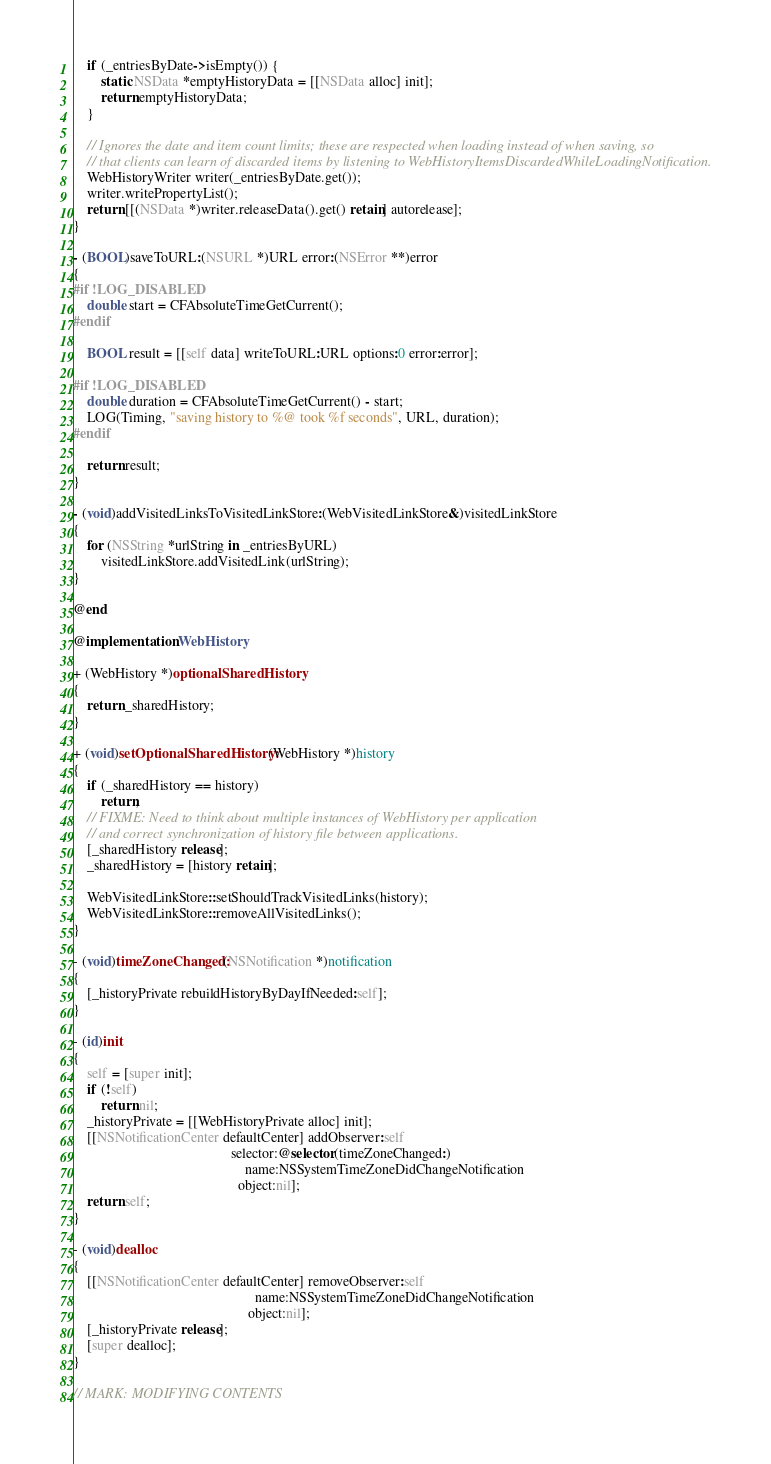Convert code to text. <code><loc_0><loc_0><loc_500><loc_500><_ObjectiveC_>    if (_entriesByDate->isEmpty()) {
        static NSData *emptyHistoryData = [[NSData alloc] init];
        return emptyHistoryData;
    }

    // Ignores the date and item count limits; these are respected when loading instead of when saving, so
    // that clients can learn of discarded items by listening to WebHistoryItemsDiscardedWhileLoadingNotification.
    WebHistoryWriter writer(_entriesByDate.get());
    writer.writePropertyList();
    return [[(NSData *)writer.releaseData().get() retain] autorelease];
}

- (BOOL)saveToURL:(NSURL *)URL error:(NSError **)error
{
#if !LOG_DISABLED
    double start = CFAbsoluteTimeGetCurrent();
#endif

    BOOL result = [[self data] writeToURL:URL options:0 error:error];

#if !LOG_DISABLED
    double duration = CFAbsoluteTimeGetCurrent() - start;
    LOG(Timing, "saving history to %@ took %f seconds", URL, duration);
#endif

    return result;
}

- (void)addVisitedLinksToVisitedLinkStore:(WebVisitedLinkStore&)visitedLinkStore
{
    for (NSString *urlString in _entriesByURL)
        visitedLinkStore.addVisitedLink(urlString);
}

@end

@implementation WebHistory

+ (WebHistory *)optionalSharedHistory
{
    return _sharedHistory;
}

+ (void)setOptionalSharedHistory:(WebHistory *)history
{
    if (_sharedHistory == history)
        return;
    // FIXME: Need to think about multiple instances of WebHistory per application
    // and correct synchronization of history file between applications.
    [_sharedHistory release];
    _sharedHistory = [history retain];

    WebVisitedLinkStore::setShouldTrackVisitedLinks(history);
    WebVisitedLinkStore::removeAllVisitedLinks();
}

- (void)timeZoneChanged:(NSNotification *)notification
{
    [_historyPrivate rebuildHistoryByDayIfNeeded:self];
}

- (id)init
{
    self = [super init];
    if (!self)
        return nil;
    _historyPrivate = [[WebHistoryPrivate alloc] init];
    [[NSNotificationCenter defaultCenter] addObserver:self
                                             selector:@selector(timeZoneChanged:)
                                                 name:NSSystemTimeZoneDidChangeNotification
                                               object:nil];
    return self;
}

- (void)dealloc
{
    [[NSNotificationCenter defaultCenter] removeObserver:self
                                                    name:NSSystemTimeZoneDidChangeNotification
                                                  object:nil];
    [_historyPrivate release];
    [super dealloc];
}

// MARK: MODIFYING CONTENTS
</code> 